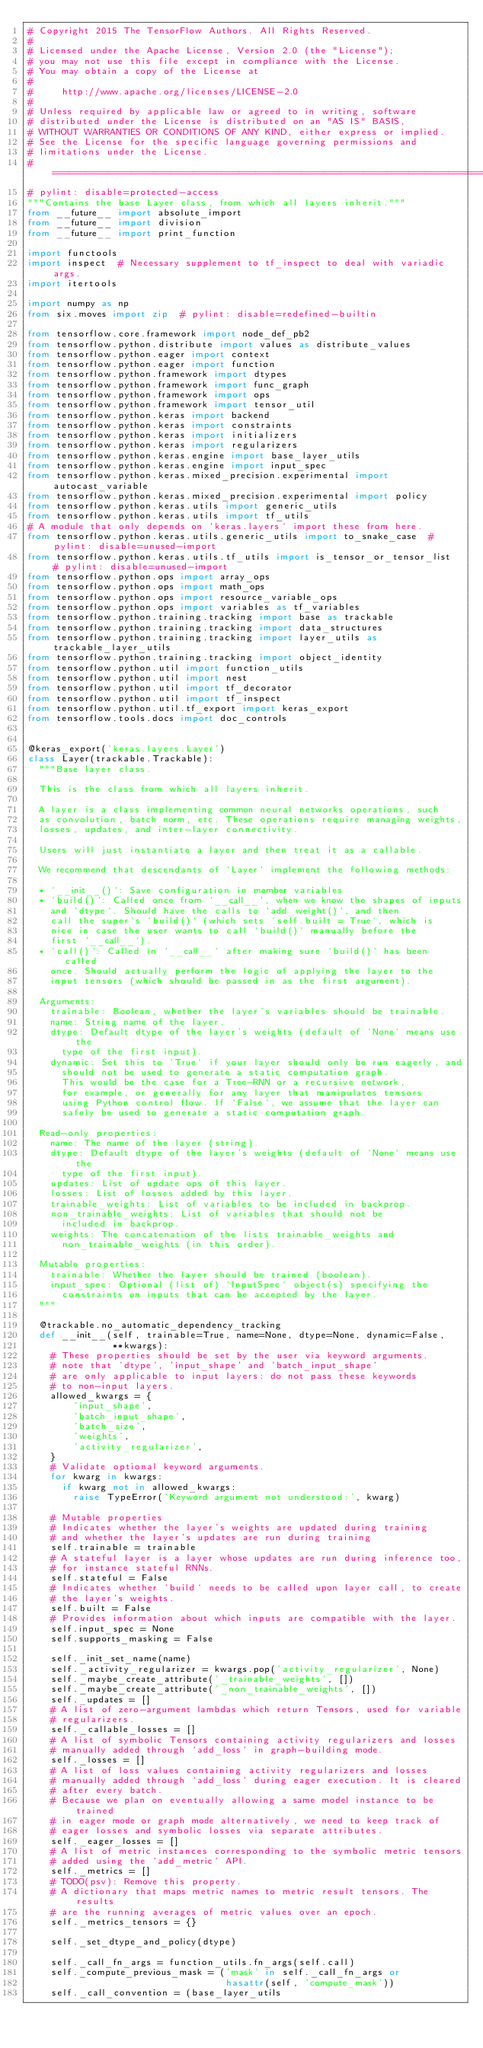Convert code to text. <code><loc_0><loc_0><loc_500><loc_500><_Python_># Copyright 2015 The TensorFlow Authors. All Rights Reserved.
#
# Licensed under the Apache License, Version 2.0 (the "License");
# you may not use this file except in compliance with the License.
# You may obtain a copy of the License at
#
#     http://www.apache.org/licenses/LICENSE-2.0
#
# Unless required by applicable law or agreed to in writing, software
# distributed under the License is distributed on an "AS IS" BASIS,
# WITHOUT WARRANTIES OR CONDITIONS OF ANY KIND, either express or implied.
# See the License for the specific language governing permissions and
# limitations under the License.
# ==============================================================================
# pylint: disable=protected-access
"""Contains the base Layer class, from which all layers inherit."""
from __future__ import absolute_import
from __future__ import division
from __future__ import print_function

import functools
import inspect  # Necessary supplement to tf_inspect to deal with variadic args.
import itertools

import numpy as np
from six.moves import zip  # pylint: disable=redefined-builtin

from tensorflow.core.framework import node_def_pb2
from tensorflow.python.distribute import values as distribute_values
from tensorflow.python.eager import context
from tensorflow.python.eager import function
from tensorflow.python.framework import dtypes
from tensorflow.python.framework import func_graph
from tensorflow.python.framework import ops
from tensorflow.python.framework import tensor_util
from tensorflow.python.keras import backend
from tensorflow.python.keras import constraints
from tensorflow.python.keras import initializers
from tensorflow.python.keras import regularizers
from tensorflow.python.keras.engine import base_layer_utils
from tensorflow.python.keras.engine import input_spec
from tensorflow.python.keras.mixed_precision.experimental import autocast_variable
from tensorflow.python.keras.mixed_precision.experimental import policy
from tensorflow.python.keras.utils import generic_utils
from tensorflow.python.keras.utils import tf_utils
# A module that only depends on `keras.layers` import these from here.
from tensorflow.python.keras.utils.generic_utils import to_snake_case  # pylint: disable=unused-import
from tensorflow.python.keras.utils.tf_utils import is_tensor_or_tensor_list  # pylint: disable=unused-import
from tensorflow.python.ops import array_ops
from tensorflow.python.ops import math_ops
from tensorflow.python.ops import resource_variable_ops
from tensorflow.python.ops import variables as tf_variables
from tensorflow.python.training.tracking import base as trackable
from tensorflow.python.training.tracking import data_structures
from tensorflow.python.training.tracking import layer_utils as trackable_layer_utils
from tensorflow.python.training.tracking import object_identity
from tensorflow.python.util import function_utils
from tensorflow.python.util import nest
from tensorflow.python.util import tf_decorator
from tensorflow.python.util import tf_inspect
from tensorflow.python.util.tf_export import keras_export
from tensorflow.tools.docs import doc_controls


@keras_export('keras.layers.Layer')
class Layer(trackable.Trackable):
  """Base layer class.

  This is the class from which all layers inherit.

  A layer is a class implementing common neural networks operations, such
  as convolution, batch norm, etc. These operations require managing weights,
  losses, updates, and inter-layer connectivity.

  Users will just instantiate a layer and then treat it as a callable.

  We recommend that descendants of `Layer` implement the following methods:

  * `__init__()`: Save configuration in member variables
  * `build()`: Called once from `__call__`, when we know the shapes of inputs
    and `dtype`. Should have the calls to `add_weight()`, and then
    call the super's `build()` (which sets `self.built = True`, which is
    nice in case the user wants to call `build()` manually before the
    first `__call__`).
  * `call()`: Called in `__call__` after making sure `build()` has been called
    once. Should actually perform the logic of applying the layer to the
    input tensors (which should be passed in as the first argument).

  Arguments:
    trainable: Boolean, whether the layer's variables should be trainable.
    name: String name of the layer.
    dtype: Default dtype of the layer's weights (default of `None` means use the
      type of the first input).
    dynamic: Set this to `True` if your layer should only be run eagerly, and
      should not be used to generate a static computation graph.
      This would be the case for a Tree-RNN or a recursive network,
      for example, or generally for any layer that manipulates tensors
      using Python control flow. If `False`, we assume that the layer can
      safely be used to generate a static computation graph.

  Read-only properties:
    name: The name of the layer (string).
    dtype: Default dtype of the layer's weights (default of `None` means use the
      type of the first input).
    updates: List of update ops of this layer.
    losses: List of losses added by this layer.
    trainable_weights: List of variables to be included in backprop.
    non_trainable_weights: List of variables that should not be
      included in backprop.
    weights: The concatenation of the lists trainable_weights and
      non_trainable_weights (in this order).

  Mutable properties:
    trainable: Whether the layer should be trained (boolean).
    input_spec: Optional (list of) `InputSpec` object(s) specifying the
      constraints on inputs that can be accepted by the layer.
  """

  @trackable.no_automatic_dependency_tracking
  def __init__(self, trainable=True, name=None, dtype=None, dynamic=False,
               **kwargs):
    # These properties should be set by the user via keyword arguments.
    # note that 'dtype', 'input_shape' and 'batch_input_shape'
    # are only applicable to input layers: do not pass these keywords
    # to non-input layers.
    allowed_kwargs = {
        'input_shape',
        'batch_input_shape',
        'batch_size',
        'weights',
        'activity_regularizer',
    }
    # Validate optional keyword arguments.
    for kwarg in kwargs:
      if kwarg not in allowed_kwargs:
        raise TypeError('Keyword argument not understood:', kwarg)

    # Mutable properties
    # Indicates whether the layer's weights are updated during training
    # and whether the layer's updates are run during training
    self.trainable = trainable
    # A stateful layer is a layer whose updates are run during inference too,
    # for instance stateful RNNs.
    self.stateful = False
    # Indicates whether `build` needs to be called upon layer call, to create
    # the layer's weights.
    self.built = False
    # Provides information about which inputs are compatible with the layer.
    self.input_spec = None
    self.supports_masking = False

    self._init_set_name(name)
    self._activity_regularizer = kwargs.pop('activity_regularizer', None)
    self._maybe_create_attribute('_trainable_weights', [])
    self._maybe_create_attribute('_non_trainable_weights', [])
    self._updates = []
    # A list of zero-argument lambdas which return Tensors, used for variable
    # regularizers.
    self._callable_losses = []
    # A list of symbolic Tensors containing activity regularizers and losses
    # manually added through `add_loss` in graph-building mode.
    self._losses = []
    # A list of loss values containing activity regularizers and losses
    # manually added through `add_loss` during eager execution. It is cleared
    # after every batch.
    # Because we plan on eventually allowing a same model instance to be trained
    # in eager mode or graph mode alternatively, we need to keep track of
    # eager losses and symbolic losses via separate attributes.
    self._eager_losses = []
    # A list of metric instances corresponding to the symbolic metric tensors
    # added using the `add_metric` API.
    self._metrics = []
    # TODO(psv): Remove this property.
    # A dictionary that maps metric names to metric result tensors. The results
    # are the running averages of metric values over an epoch.
    self._metrics_tensors = {}

    self._set_dtype_and_policy(dtype)

    self._call_fn_args = function_utils.fn_args(self.call)
    self._compute_previous_mask = ('mask' in self._call_fn_args or
                                   hasattr(self, 'compute_mask'))
    self._call_convention = (base_layer_utils</code> 